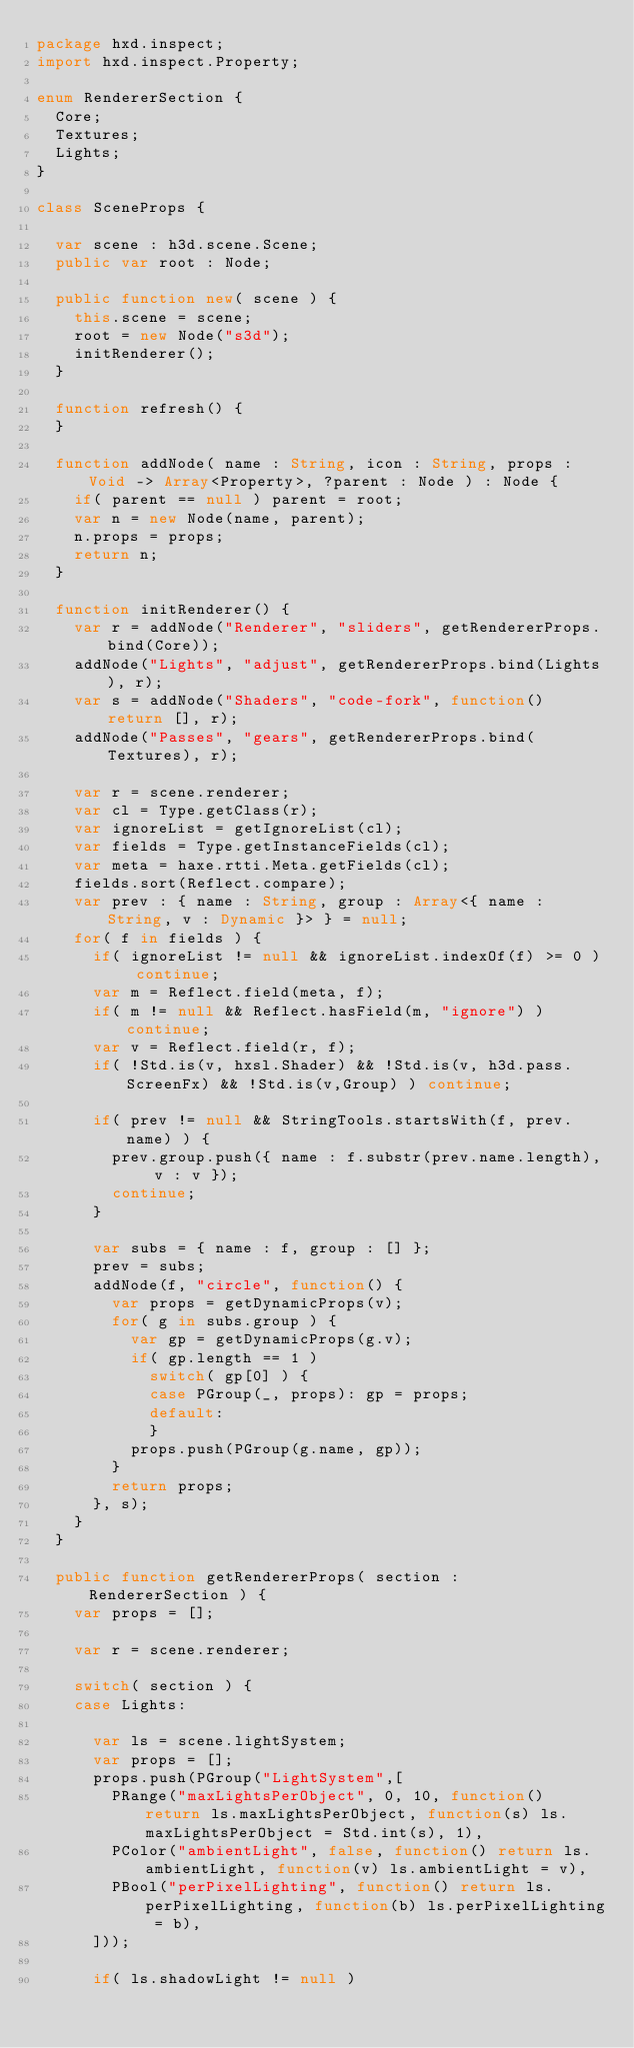<code> <loc_0><loc_0><loc_500><loc_500><_Haxe_>package hxd.inspect;
import hxd.inspect.Property;

enum RendererSection {
	Core;
	Textures;
	Lights;
}

class SceneProps {

	var scene : h3d.scene.Scene;
	public var root : Node;

	public function new( scene ) {
		this.scene = scene;
		root = new Node("s3d");
		initRenderer();
	}

	function refresh() {
	}

	function addNode( name : String, icon : String, props : Void -> Array<Property>, ?parent : Node ) : Node {
		if( parent == null ) parent = root;
		var n = new Node(name, parent);
		n.props = props;
		return n;
	}

	function initRenderer() {
		var r = addNode("Renderer", "sliders", getRendererProps.bind(Core));
		addNode("Lights", "adjust", getRendererProps.bind(Lights), r);
		var s = addNode("Shaders", "code-fork", function() return [], r);
		addNode("Passes", "gears", getRendererProps.bind(Textures), r);

		var r = scene.renderer;
		var cl = Type.getClass(r);
		var ignoreList = getIgnoreList(cl);
		var fields = Type.getInstanceFields(cl);
		var meta = haxe.rtti.Meta.getFields(cl);
		fields.sort(Reflect.compare);
		var prev : { name : String, group : Array<{ name : String, v : Dynamic }> } = null;
		for( f in fields ) {
			if( ignoreList != null && ignoreList.indexOf(f) >= 0 ) continue;
			var m = Reflect.field(meta, f);
			if( m != null && Reflect.hasField(m, "ignore") ) continue;
			var v = Reflect.field(r, f);
			if( !Std.is(v, hxsl.Shader) && !Std.is(v, h3d.pass.ScreenFx) && !Std.is(v,Group) ) continue;

			if( prev != null && StringTools.startsWith(f, prev.name) ) {
				prev.group.push({ name : f.substr(prev.name.length), v : v });
				continue;
			}

			var subs = { name : f, group : [] };
			prev = subs;
			addNode(f, "circle", function() {
				var props = getDynamicProps(v);
				for( g in subs.group ) {
					var gp = getDynamicProps(g.v);
					if( gp.length == 1 )
						switch( gp[0] ) {
						case PGroup(_, props): gp = props;
						default:
						}
					props.push(PGroup(g.name, gp));
				}
				return props;
			}, s);
		}
	}

	public function getRendererProps( section : RendererSection ) {
		var props = [];

		var r = scene.renderer;

		switch( section ) {
		case Lights:

			var ls = scene.lightSystem;
			var props = [];
			props.push(PGroup("LightSystem",[
				PRange("maxLightsPerObject", 0, 10, function() return ls.maxLightsPerObject, function(s) ls.maxLightsPerObject = Std.int(s), 1),
				PColor("ambientLight", false, function() return ls.ambientLight, function(v) ls.ambientLight = v),
				PBool("perPixelLighting", function() return ls.perPixelLighting, function(b) ls.perPixelLighting = b),
			]));

			if( ls.shadowLight != null )</code> 